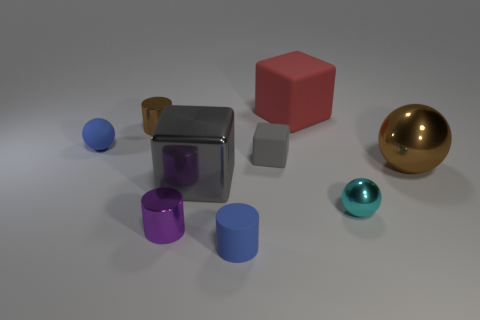Add 1 shiny cylinders. How many objects exist? 10 Subtract all balls. How many objects are left? 6 Subtract 0 purple balls. How many objects are left? 9 Subtract all green matte spheres. Subtract all small purple metal things. How many objects are left? 8 Add 6 large objects. How many large objects are left? 9 Add 6 blue rubber blocks. How many blue rubber blocks exist? 6 